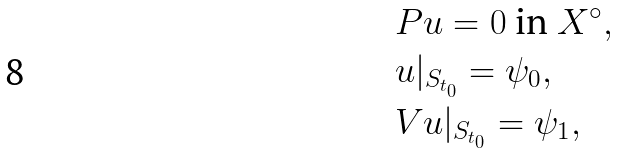<formula> <loc_0><loc_0><loc_500><loc_500>& P u = 0 \ \text {in} \ X ^ { \circ } , \\ & u | _ { S _ { t _ { 0 } } } = \psi _ { 0 } , \\ & V u | _ { S _ { t _ { 0 } } } = \psi _ { 1 } ,</formula> 